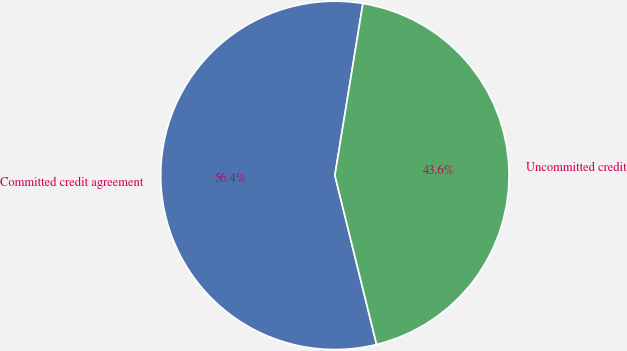Convert chart. <chart><loc_0><loc_0><loc_500><loc_500><pie_chart><fcel>Committed credit agreement<fcel>Uncommitted credit<nl><fcel>56.42%<fcel>43.58%<nl></chart> 